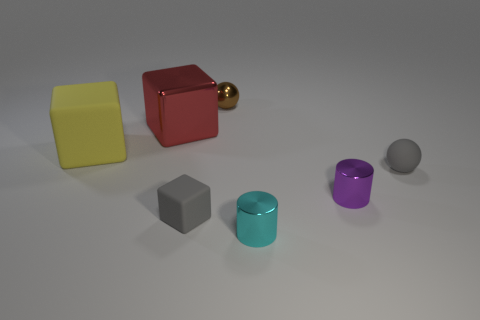Subtract all big cubes. How many cubes are left? 1 Add 3 brown metallic objects. How many objects exist? 10 Subtract 1 spheres. How many spheres are left? 1 Subtract all spheres. How many objects are left? 5 Subtract all cyan cubes. Subtract all yellow spheres. How many cubes are left? 3 Add 4 tiny gray rubber blocks. How many tiny gray rubber blocks are left? 5 Add 5 cyan metal cylinders. How many cyan metal cylinders exist? 6 Subtract 0 cyan balls. How many objects are left? 7 Subtract all tiny metallic cubes. Subtract all tiny rubber cubes. How many objects are left? 6 